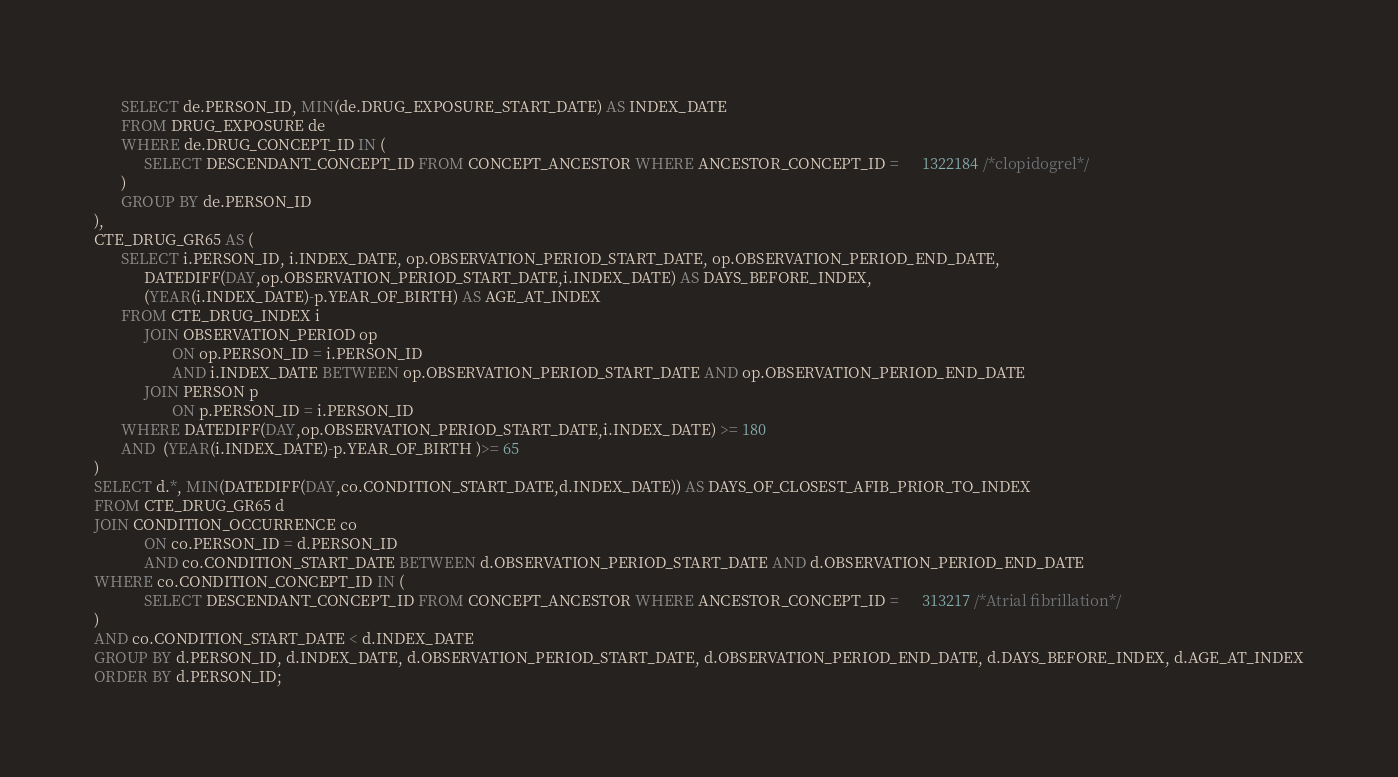Convert code to text. <code><loc_0><loc_0><loc_500><loc_500><_SQL_>       SELECT de.PERSON_ID, MIN(de.DRUG_EXPOSURE_START_DATE) AS INDEX_DATE
       FROM DRUG_EXPOSURE de
       WHERE de.DRUG_CONCEPT_ID IN (
             SELECT DESCENDANT_CONCEPT_ID FROM CONCEPT_ANCESTOR WHERE ANCESTOR_CONCEPT_ID =      1322184 /*clopidogrel*/
       )
       GROUP BY de.PERSON_ID
), 
CTE_DRUG_GR65 AS (
       SELECT i.PERSON_ID, i.INDEX_DATE, op.OBSERVATION_PERIOD_START_DATE, op.OBSERVATION_PERIOD_END_DATE,
             DATEDIFF(DAY,op.OBSERVATION_PERIOD_START_DATE,i.INDEX_DATE) AS DAYS_BEFORE_INDEX, 
             (YEAR(i.INDEX_DATE)-p.YEAR_OF_BIRTH) AS AGE_AT_INDEX
       FROM CTE_DRUG_INDEX i
             JOIN OBSERVATION_PERIOD op
                    ON op.PERSON_ID = i.PERSON_ID
                    AND i.INDEX_DATE BETWEEN op.OBSERVATION_PERIOD_START_DATE AND op.OBSERVATION_PERIOD_END_DATE
             JOIN PERSON p
                    ON p.PERSON_ID = i.PERSON_ID
       WHERE DATEDIFF(DAY,op.OBSERVATION_PERIOD_START_DATE,i.INDEX_DATE) >= 180
       AND  (YEAR(i.INDEX_DATE)-p.YEAR_OF_BIRTH )>= 65
)
SELECT d.*, MIN(DATEDIFF(DAY,co.CONDITION_START_DATE,d.INDEX_DATE)) AS DAYS_OF_CLOSEST_AFIB_PRIOR_TO_INDEX
FROM CTE_DRUG_GR65 d
JOIN CONDITION_OCCURRENCE co
             ON co.PERSON_ID = d.PERSON_ID
             AND co.CONDITION_START_DATE BETWEEN d.OBSERVATION_PERIOD_START_DATE AND d.OBSERVATION_PERIOD_END_DATE
WHERE co.CONDITION_CONCEPT_ID IN (
             SELECT DESCENDANT_CONCEPT_ID FROM CONCEPT_ANCESTOR WHERE ANCESTOR_CONCEPT_ID =      313217 /*Atrial fibrillation*/           
)
AND co.CONDITION_START_DATE < d.INDEX_DATE
GROUP BY d.PERSON_ID, d.INDEX_DATE, d.OBSERVATION_PERIOD_START_DATE, d.OBSERVATION_PERIOD_END_DATE, d.DAYS_BEFORE_INDEX, d.AGE_AT_INDEX
ORDER BY d.PERSON_ID;</code> 